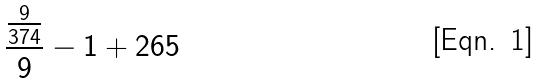Convert formula to latex. <formula><loc_0><loc_0><loc_500><loc_500>\frac { \frac { 9 } { 3 7 4 } } { 9 } - 1 + 2 6 5</formula> 